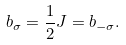<formula> <loc_0><loc_0><loc_500><loc_500>b _ { \sigma } = \frac { 1 } { 2 } J = b _ { - \sigma } .</formula> 